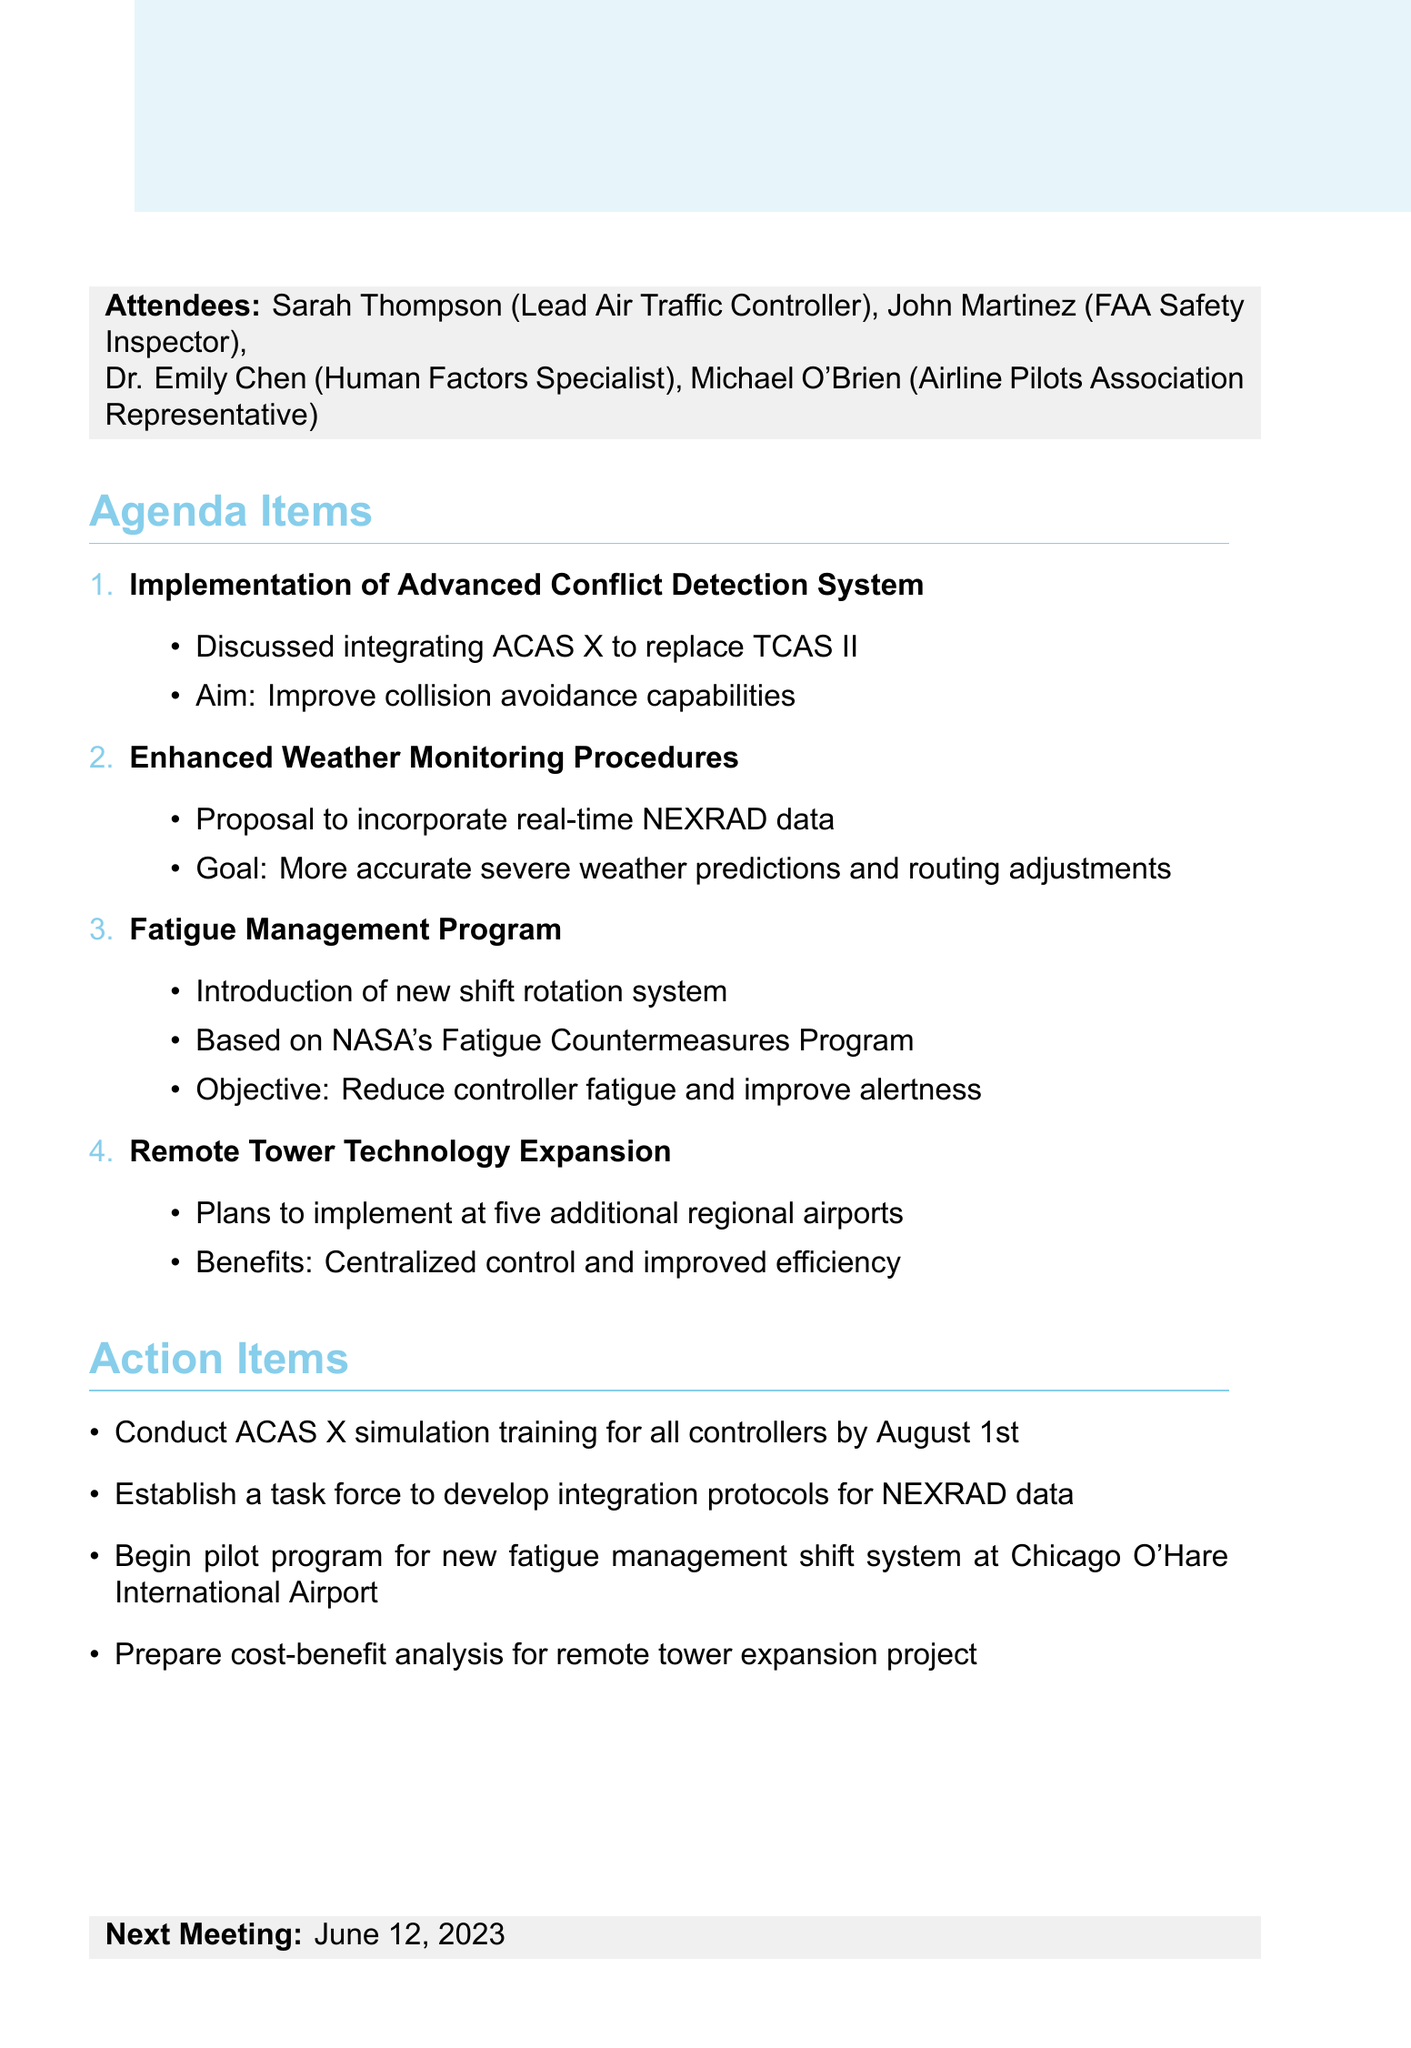What is the date of the meeting? The date of the meeting is explicitly mentioned in the document.
Answer: May 15, 2023 Who is the lead air traffic controller? The document states the name of the lead air traffic controller among the attendees.
Answer: Sarah Thompson What is the first agenda item discussed? The first item listed in the agenda items section of the document is what we need.
Answer: Implementation of Advanced Conflict Detection System What is the next meeting date? The next meeting date is provided at the end of the document.
Answer: June 12, 2023 How many regional airports will have remote tower systems implemented? The document specifies the number of airports that will have this system implemented.
Answer: Five What is the goal of the Enhanced Weather Monitoring Procedures? The goal mentioned in the agenda for this item provides insight into its purpose.
Answer: More accurate severe weather predictions and routing adjustments What training is scheduled to be conducted by August 1st? The action item related to training provides the specific detail requested.
Answer: ACAS X simulation training What program is the Fatigue Management Program based on? The document mentions the specific program that influences the new shift rotation system.
Answer: NASA's Fatigue Countermeasures Program 